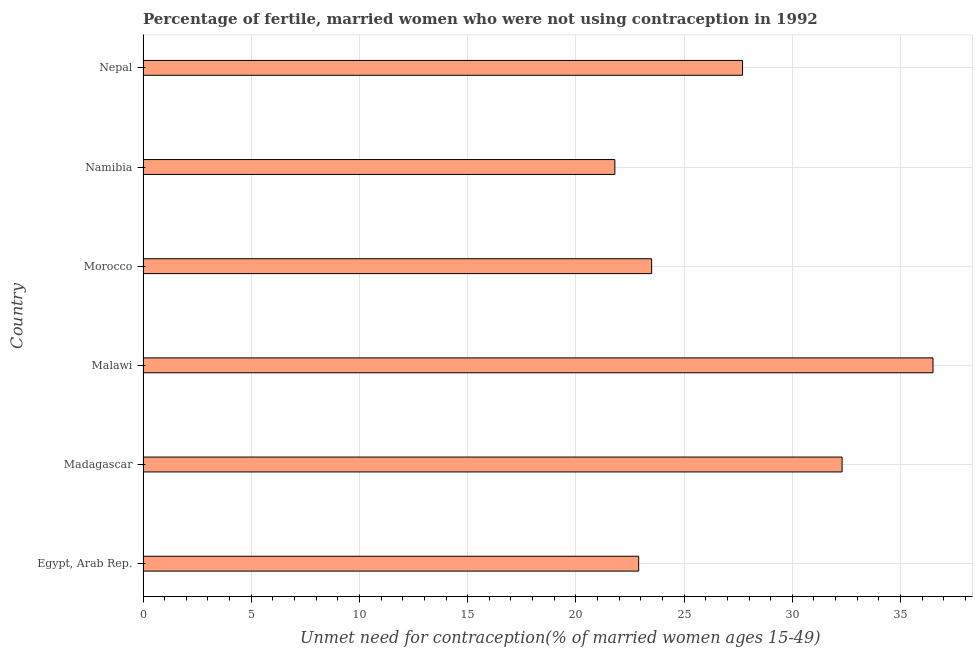What is the title of the graph?
Provide a short and direct response. Percentage of fertile, married women who were not using contraception in 1992. What is the label or title of the X-axis?
Ensure brevity in your answer.   Unmet need for contraception(% of married women ages 15-49). What is the number of married women who are not using contraception in Egypt, Arab Rep.?
Offer a very short reply. 22.9. Across all countries, what is the maximum number of married women who are not using contraception?
Provide a succinct answer. 36.5. Across all countries, what is the minimum number of married women who are not using contraception?
Provide a succinct answer. 21.8. In which country was the number of married women who are not using contraception maximum?
Make the answer very short. Malawi. In which country was the number of married women who are not using contraception minimum?
Offer a terse response. Namibia. What is the sum of the number of married women who are not using contraception?
Your answer should be compact. 164.7. What is the difference between the number of married women who are not using contraception in Egypt, Arab Rep. and Nepal?
Ensure brevity in your answer.  -4.8. What is the average number of married women who are not using contraception per country?
Ensure brevity in your answer.  27.45. What is the median number of married women who are not using contraception?
Make the answer very short. 25.6. In how many countries, is the number of married women who are not using contraception greater than 29 %?
Offer a very short reply. 2. What is the ratio of the number of married women who are not using contraception in Egypt, Arab Rep. to that in Madagascar?
Provide a short and direct response. 0.71. What is the difference between the highest and the second highest number of married women who are not using contraception?
Give a very brief answer. 4.2. Is the sum of the number of married women who are not using contraception in Madagascar and Namibia greater than the maximum number of married women who are not using contraception across all countries?
Your answer should be compact. Yes. What is the difference between the highest and the lowest number of married women who are not using contraception?
Provide a succinct answer. 14.7. In how many countries, is the number of married women who are not using contraception greater than the average number of married women who are not using contraception taken over all countries?
Offer a terse response. 3. Are all the bars in the graph horizontal?
Your answer should be compact. Yes. How many countries are there in the graph?
Offer a very short reply. 6. What is the difference between two consecutive major ticks on the X-axis?
Offer a very short reply. 5. What is the  Unmet need for contraception(% of married women ages 15-49) of Egypt, Arab Rep.?
Your answer should be compact. 22.9. What is the  Unmet need for contraception(% of married women ages 15-49) of Madagascar?
Provide a succinct answer. 32.3. What is the  Unmet need for contraception(% of married women ages 15-49) of Malawi?
Give a very brief answer. 36.5. What is the  Unmet need for contraception(% of married women ages 15-49) of Morocco?
Give a very brief answer. 23.5. What is the  Unmet need for contraception(% of married women ages 15-49) of Namibia?
Offer a very short reply. 21.8. What is the  Unmet need for contraception(% of married women ages 15-49) in Nepal?
Provide a short and direct response. 27.7. What is the difference between the  Unmet need for contraception(% of married women ages 15-49) in Egypt, Arab Rep. and Madagascar?
Ensure brevity in your answer.  -9.4. What is the difference between the  Unmet need for contraception(% of married women ages 15-49) in Madagascar and Malawi?
Keep it short and to the point. -4.2. What is the difference between the  Unmet need for contraception(% of married women ages 15-49) in Malawi and Morocco?
Make the answer very short. 13. What is the difference between the  Unmet need for contraception(% of married women ages 15-49) in Morocco and Namibia?
Provide a succinct answer. 1.7. What is the difference between the  Unmet need for contraception(% of married women ages 15-49) in Namibia and Nepal?
Offer a very short reply. -5.9. What is the ratio of the  Unmet need for contraception(% of married women ages 15-49) in Egypt, Arab Rep. to that in Madagascar?
Offer a terse response. 0.71. What is the ratio of the  Unmet need for contraception(% of married women ages 15-49) in Egypt, Arab Rep. to that in Malawi?
Provide a succinct answer. 0.63. What is the ratio of the  Unmet need for contraception(% of married women ages 15-49) in Egypt, Arab Rep. to that in Morocco?
Provide a succinct answer. 0.97. What is the ratio of the  Unmet need for contraception(% of married women ages 15-49) in Egypt, Arab Rep. to that in Namibia?
Offer a very short reply. 1.05. What is the ratio of the  Unmet need for contraception(% of married women ages 15-49) in Egypt, Arab Rep. to that in Nepal?
Your response must be concise. 0.83. What is the ratio of the  Unmet need for contraception(% of married women ages 15-49) in Madagascar to that in Malawi?
Offer a very short reply. 0.89. What is the ratio of the  Unmet need for contraception(% of married women ages 15-49) in Madagascar to that in Morocco?
Give a very brief answer. 1.37. What is the ratio of the  Unmet need for contraception(% of married women ages 15-49) in Madagascar to that in Namibia?
Ensure brevity in your answer.  1.48. What is the ratio of the  Unmet need for contraception(% of married women ages 15-49) in Madagascar to that in Nepal?
Provide a short and direct response. 1.17. What is the ratio of the  Unmet need for contraception(% of married women ages 15-49) in Malawi to that in Morocco?
Offer a terse response. 1.55. What is the ratio of the  Unmet need for contraception(% of married women ages 15-49) in Malawi to that in Namibia?
Make the answer very short. 1.67. What is the ratio of the  Unmet need for contraception(% of married women ages 15-49) in Malawi to that in Nepal?
Ensure brevity in your answer.  1.32. What is the ratio of the  Unmet need for contraception(% of married women ages 15-49) in Morocco to that in Namibia?
Your response must be concise. 1.08. What is the ratio of the  Unmet need for contraception(% of married women ages 15-49) in Morocco to that in Nepal?
Provide a short and direct response. 0.85. What is the ratio of the  Unmet need for contraception(% of married women ages 15-49) in Namibia to that in Nepal?
Give a very brief answer. 0.79. 